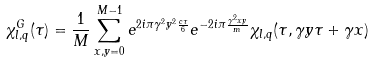<formula> <loc_0><loc_0><loc_500><loc_500>\chi ^ { G } _ { l , q } ( \tau ) = \frac { 1 } { M } \sum _ { x , y = 0 } ^ { M - 1 } e ^ { 2 i \pi \gamma ^ { 2 } y ^ { 2 } { \frac { c \tau } { 6 } } } e ^ { - 2 i \pi { \frac { \gamma ^ { 2 } x y } { m } } } \chi _ { l , q } ( \tau , \gamma y \tau + \gamma x )</formula> 